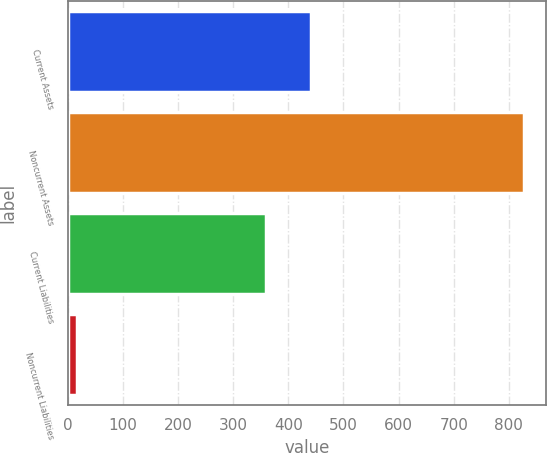Convert chart. <chart><loc_0><loc_0><loc_500><loc_500><bar_chart><fcel>Current Assets<fcel>Noncurrent Assets<fcel>Current Liabilities<fcel>Noncurrent Liabilities<nl><fcel>441.1<fcel>827<fcel>360<fcel>16<nl></chart> 